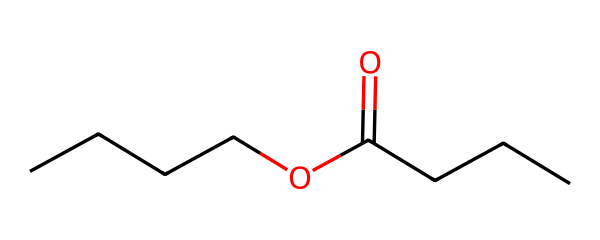What is the molecular formula of butyl butyrate? To determine the molecular formula, count the number of each type of atom in the chemical structure. The structure contains 8 carbon atoms (C), 16 hydrogen atoms (H), and 2 oxygen atoms (O). Therefore, the molecular formula is C8H16O2.
Answer: C8H16O2 How many carbon atoms are present in butyl butyrate? In the SMILES representation, each 'C' represents a carbon atom. Counting the 'C's in the structure gives a total of 8 carbon atoms.
Answer: 8 What functional group is present in butyl butyrate? The structure contains a carbonyl group (C=O) and an alkoxy group (−O−), which collectively indicate the presence of an ester functional group.
Answer: ester What is the number of hydrogen atoms connected to the carbon atoms in butyl butyrate? The number of hydrogen atoms can be inferred from the structure by considering the tetravalence of carbon. Each carbon atom here is connected according to the bonding rules, resulting in a total of 16 hydrogens based on the structure.
Answer: 16 How many oxygen atoms are in butyl butyrate? From the chemical structure, there are two 'O' symbols present, indicating there are two oxygen atoms in the molecule.
Answer: 2 What type of ester is butyl butyrate? Butyl butyrate is classified as a simple ester formed from butanol and butanoic acid, indicating it is an aliphatic ester.
Answer: aliphatic What characteristic does butyl butyrate give to food products? Butyl butyrate is known to impart a fruity flavor to food products, commonly used in flavoring agents due to its pleasant scent and taste.
Answer: fruity flavor 